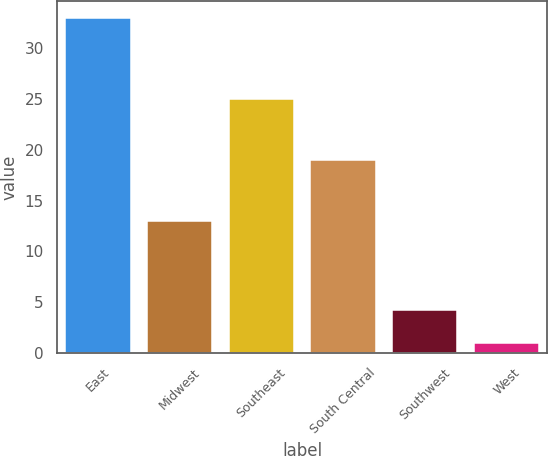Convert chart to OTSL. <chart><loc_0><loc_0><loc_500><loc_500><bar_chart><fcel>East<fcel>Midwest<fcel>Southeast<fcel>South Central<fcel>Southwest<fcel>West<nl><fcel>33<fcel>13<fcel>25<fcel>19<fcel>4.2<fcel>1<nl></chart> 